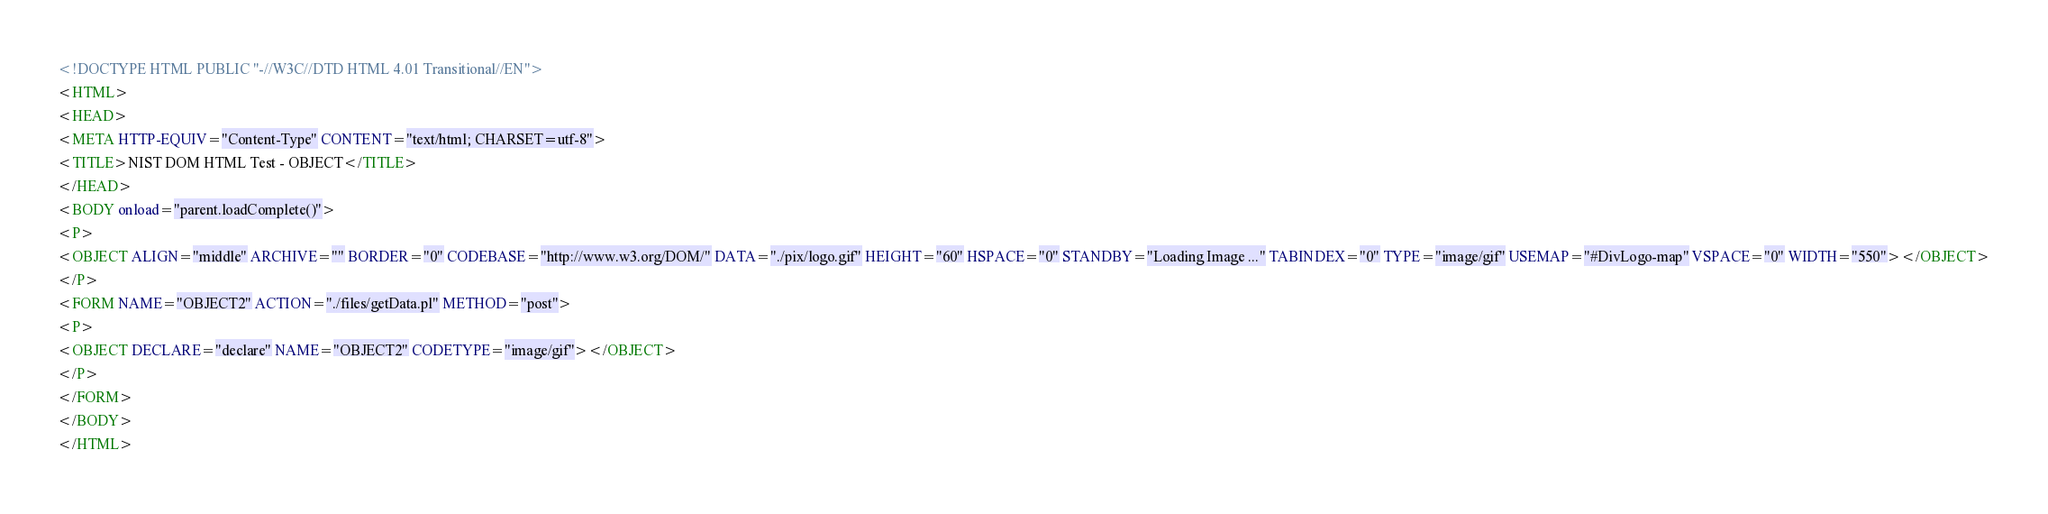Convert code to text. <code><loc_0><loc_0><loc_500><loc_500><_HTML_><!DOCTYPE HTML PUBLIC "-//W3C//DTD HTML 4.01 Transitional//EN">
<HTML>
<HEAD>
<META HTTP-EQUIV="Content-Type" CONTENT="text/html; CHARSET=utf-8">
<TITLE>NIST DOM HTML Test - OBJECT</TITLE>
</HEAD>
<BODY onload="parent.loadComplete()">
<P>
<OBJECT ALIGN="middle" ARCHIVE="" BORDER="0" CODEBASE="http://www.w3.org/DOM/" DATA="./pix/logo.gif" HEIGHT="60" HSPACE="0" STANDBY="Loading Image ..." TABINDEX="0" TYPE="image/gif" USEMAP="#DivLogo-map" VSPACE="0" WIDTH="550"></OBJECT>
</P>
<FORM NAME="OBJECT2" ACTION="./files/getData.pl" METHOD="post">
<P>
<OBJECT DECLARE="declare" NAME="OBJECT2" CODETYPE="image/gif"></OBJECT>
</P>
</FORM>
</BODY>
</HTML>

</code> 